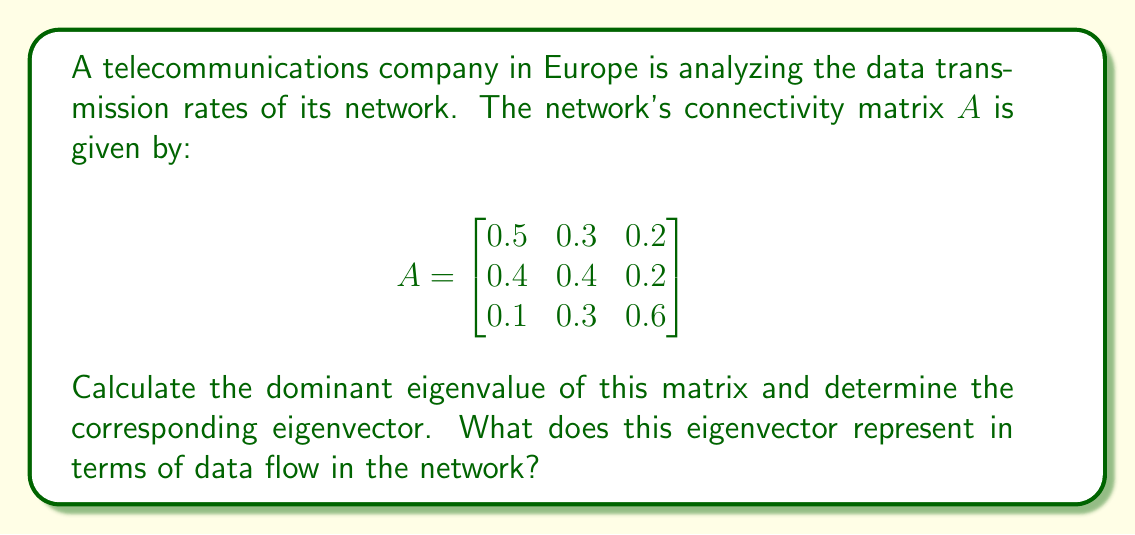Can you solve this math problem? To solve this problem, we need to follow these steps:

1. Find the characteristic equation of matrix $A$:
   $det(A - \lambda I) = 0$

2. Solve the characteristic equation to find the eigenvalues.

3. Find the largest eigenvalue (dominant eigenvalue).

4. Calculate the eigenvector corresponding to the dominant eigenvalue.

5. Interpret the result in terms of data flow.

Step 1: Characteristic equation
$$det(A - \lambda I) = \begin{vmatrix}
0.5-\lambda & 0.3 & 0.2 \\
0.4 & 0.4-\lambda & 0.2 \\
0.1 & 0.3 & 0.6-\lambda
\end{vmatrix} = 0$$

Step 2: Expanding the determinant:
$$(0.5-\lambda)((0.4-\lambda)(0.6-\lambda)-0.06) - 0.3(0.4(0.6-\lambda)-0.02) + 0.2(0.12-0.3(0.4-\lambda)) = 0$$

Simplifying:
$$-\lambda^3 + 1.5\lambda^2 - 0.71\lambda + 0.106 = 0$$

Step 3: Solving this cubic equation (using numerical methods or a calculator), we get:
$\lambda_1 \approx 1.0000$
$\lambda_2 \approx 0.2722$
$\lambda_3 \approx 0.2278$

The dominant eigenvalue is $\lambda_1 = 1$.

Step 4: To find the eigenvector $v$ corresponding to $\lambda_1 = 1$, we solve:
$$(A - I)v = 0$$

$$\begin{bmatrix}
-0.5 & 0.3 & 0.2 \\
0.4 & -0.6 & 0.2 \\
0.1 & 0.3 & -0.4
\end{bmatrix} \begin{bmatrix} v_1 \\ v_2 \\ v_3 \end{bmatrix} = \begin{bmatrix} 0 \\ 0 \\ 0 \end{bmatrix}$$

Solving this system (and normalizing), we get:
$$v \approx \begin{bmatrix} 0.5774 \\ 0.5774 \\ 0.5774 \end{bmatrix}$$

Step 5: Interpretation
The eigenvector corresponding to the dominant eigenvalue represents the stable state distribution of data flow in the network. Each component of the eigenvector represents the relative amount of data flowing through each node in the long-term equilibrium state.

In this case, the eigenvector shows that the data flow is equally distributed among all three nodes of the network, as all components are approximately equal.
Answer: The dominant eigenvalue is 1, and the corresponding normalized eigenvector is approximately $[0.5774, 0.5774, 0.5774]^T$. This eigenvector indicates that in the long-term equilibrium state, the data flow is equally distributed among all three nodes of the network. 